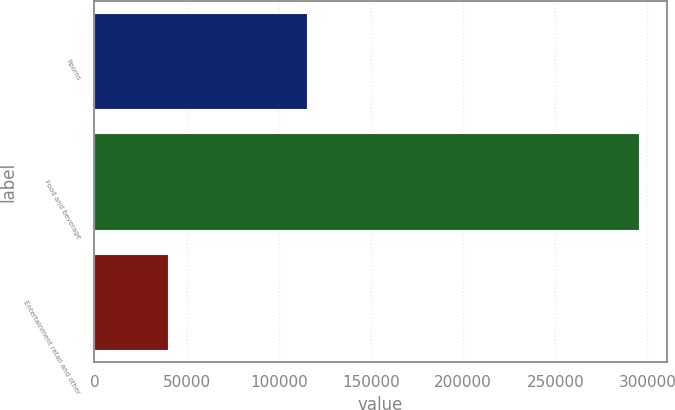<chart> <loc_0><loc_0><loc_500><loc_500><bar_chart><fcel>Rooms<fcel>Food and beverage<fcel>Entertainment retail and other<nl><fcel>115463<fcel>295667<fcel>39673<nl></chart> 